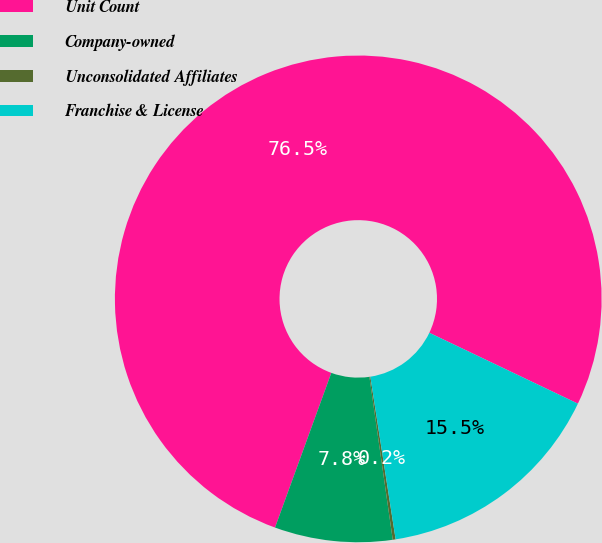<chart> <loc_0><loc_0><loc_500><loc_500><pie_chart><fcel>Unit Count<fcel>Company-owned<fcel>Unconsolidated Affiliates<fcel>Franchise & License<nl><fcel>76.53%<fcel>7.82%<fcel>0.19%<fcel>15.46%<nl></chart> 